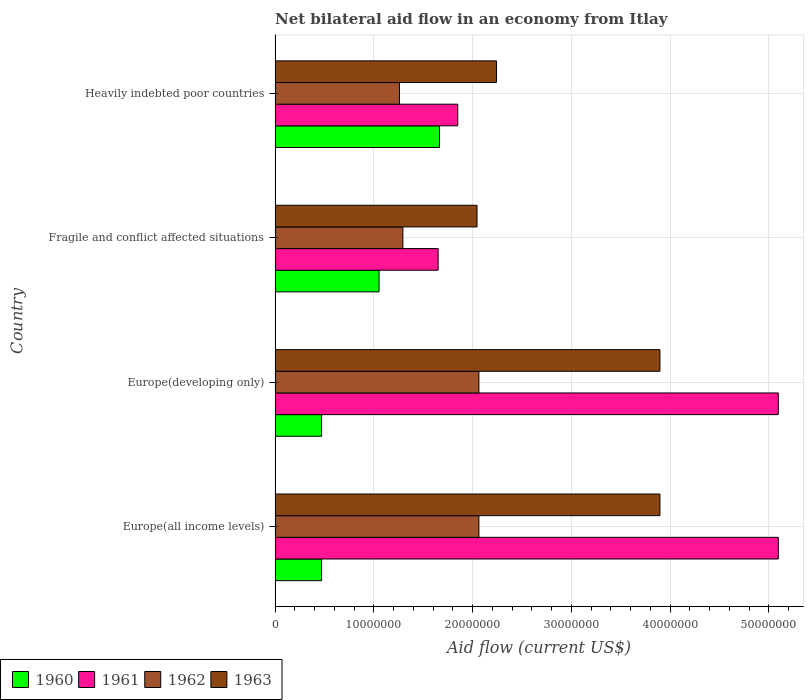Are the number of bars per tick equal to the number of legend labels?
Your answer should be very brief. Yes. Are the number of bars on each tick of the Y-axis equal?
Offer a terse response. Yes. How many bars are there on the 2nd tick from the top?
Your answer should be compact. 4. What is the label of the 4th group of bars from the top?
Ensure brevity in your answer.  Europe(all income levels). What is the net bilateral aid flow in 1963 in Europe(developing only)?
Provide a short and direct response. 3.90e+07. Across all countries, what is the maximum net bilateral aid flow in 1961?
Provide a succinct answer. 5.10e+07. Across all countries, what is the minimum net bilateral aid flow in 1960?
Your answer should be compact. 4.71e+06. In which country was the net bilateral aid flow in 1963 maximum?
Ensure brevity in your answer.  Europe(all income levels). In which country was the net bilateral aid flow in 1961 minimum?
Make the answer very short. Fragile and conflict affected situations. What is the total net bilateral aid flow in 1962 in the graph?
Your response must be concise. 6.68e+07. What is the difference between the net bilateral aid flow in 1961 in Fragile and conflict affected situations and that in Heavily indebted poor countries?
Ensure brevity in your answer.  -1.99e+06. What is the difference between the net bilateral aid flow in 1960 in Heavily indebted poor countries and the net bilateral aid flow in 1962 in Europe(all income levels)?
Offer a terse response. -3.99e+06. What is the average net bilateral aid flow in 1960 per country?
Offer a very short reply. 9.15e+06. What is the difference between the net bilateral aid flow in 1960 and net bilateral aid flow in 1961 in Fragile and conflict affected situations?
Ensure brevity in your answer.  -5.98e+06. What is the ratio of the net bilateral aid flow in 1961 in Europe(developing only) to that in Fragile and conflict affected situations?
Your answer should be compact. 3.09. Is the net bilateral aid flow in 1961 in Europe(all income levels) less than that in Europe(developing only)?
Your answer should be very brief. No. What is the difference between the highest and the second highest net bilateral aid flow in 1960?
Give a very brief answer. 6.12e+06. What is the difference between the highest and the lowest net bilateral aid flow in 1960?
Give a very brief answer. 1.19e+07. In how many countries, is the net bilateral aid flow in 1962 greater than the average net bilateral aid flow in 1962 taken over all countries?
Your response must be concise. 2. Is the sum of the net bilateral aid flow in 1960 in Europe(all income levels) and Heavily indebted poor countries greater than the maximum net bilateral aid flow in 1961 across all countries?
Offer a very short reply. No. What does the 4th bar from the top in Europe(all income levels) represents?
Provide a succinct answer. 1960. How many bars are there?
Your response must be concise. 16. What is the difference between two consecutive major ticks on the X-axis?
Make the answer very short. 1.00e+07. Does the graph contain any zero values?
Make the answer very short. No. Where does the legend appear in the graph?
Provide a short and direct response. Bottom left. How many legend labels are there?
Your response must be concise. 4. What is the title of the graph?
Your response must be concise. Net bilateral aid flow in an economy from Itlay. Does "2001" appear as one of the legend labels in the graph?
Keep it short and to the point. No. What is the label or title of the X-axis?
Your answer should be very brief. Aid flow (current US$). What is the label or title of the Y-axis?
Ensure brevity in your answer.  Country. What is the Aid flow (current US$) of 1960 in Europe(all income levels)?
Your answer should be compact. 4.71e+06. What is the Aid flow (current US$) in 1961 in Europe(all income levels)?
Ensure brevity in your answer.  5.10e+07. What is the Aid flow (current US$) in 1962 in Europe(all income levels)?
Give a very brief answer. 2.06e+07. What is the Aid flow (current US$) of 1963 in Europe(all income levels)?
Offer a very short reply. 3.90e+07. What is the Aid flow (current US$) of 1960 in Europe(developing only)?
Provide a short and direct response. 4.71e+06. What is the Aid flow (current US$) of 1961 in Europe(developing only)?
Make the answer very short. 5.10e+07. What is the Aid flow (current US$) of 1962 in Europe(developing only)?
Provide a succinct answer. 2.06e+07. What is the Aid flow (current US$) in 1963 in Europe(developing only)?
Your response must be concise. 3.90e+07. What is the Aid flow (current US$) of 1960 in Fragile and conflict affected situations?
Make the answer very short. 1.05e+07. What is the Aid flow (current US$) in 1961 in Fragile and conflict affected situations?
Your answer should be compact. 1.65e+07. What is the Aid flow (current US$) in 1962 in Fragile and conflict affected situations?
Offer a terse response. 1.29e+07. What is the Aid flow (current US$) of 1963 in Fragile and conflict affected situations?
Provide a short and direct response. 2.04e+07. What is the Aid flow (current US$) in 1960 in Heavily indebted poor countries?
Make the answer very short. 1.66e+07. What is the Aid flow (current US$) in 1961 in Heavily indebted poor countries?
Provide a short and direct response. 1.85e+07. What is the Aid flow (current US$) in 1962 in Heavily indebted poor countries?
Your answer should be compact. 1.26e+07. What is the Aid flow (current US$) in 1963 in Heavily indebted poor countries?
Ensure brevity in your answer.  2.24e+07. Across all countries, what is the maximum Aid flow (current US$) in 1960?
Your answer should be compact. 1.66e+07. Across all countries, what is the maximum Aid flow (current US$) in 1961?
Provide a succinct answer. 5.10e+07. Across all countries, what is the maximum Aid flow (current US$) in 1962?
Provide a succinct answer. 2.06e+07. Across all countries, what is the maximum Aid flow (current US$) in 1963?
Offer a terse response. 3.90e+07. Across all countries, what is the minimum Aid flow (current US$) of 1960?
Your answer should be compact. 4.71e+06. Across all countries, what is the minimum Aid flow (current US$) in 1961?
Your response must be concise. 1.65e+07. Across all countries, what is the minimum Aid flow (current US$) in 1962?
Provide a succinct answer. 1.26e+07. Across all countries, what is the minimum Aid flow (current US$) of 1963?
Ensure brevity in your answer.  2.04e+07. What is the total Aid flow (current US$) in 1960 in the graph?
Ensure brevity in your answer.  3.66e+07. What is the total Aid flow (current US$) in 1961 in the graph?
Your response must be concise. 1.37e+08. What is the total Aid flow (current US$) in 1962 in the graph?
Provide a short and direct response. 6.68e+07. What is the total Aid flow (current US$) of 1963 in the graph?
Give a very brief answer. 1.21e+08. What is the difference between the Aid flow (current US$) in 1960 in Europe(all income levels) and that in Europe(developing only)?
Make the answer very short. 0. What is the difference between the Aid flow (current US$) of 1962 in Europe(all income levels) and that in Europe(developing only)?
Your answer should be compact. 0. What is the difference between the Aid flow (current US$) in 1963 in Europe(all income levels) and that in Europe(developing only)?
Offer a terse response. 0. What is the difference between the Aid flow (current US$) of 1960 in Europe(all income levels) and that in Fragile and conflict affected situations?
Your answer should be very brief. -5.82e+06. What is the difference between the Aid flow (current US$) of 1961 in Europe(all income levels) and that in Fragile and conflict affected situations?
Make the answer very short. 3.44e+07. What is the difference between the Aid flow (current US$) in 1962 in Europe(all income levels) and that in Fragile and conflict affected situations?
Ensure brevity in your answer.  7.70e+06. What is the difference between the Aid flow (current US$) of 1963 in Europe(all income levels) and that in Fragile and conflict affected situations?
Ensure brevity in your answer.  1.85e+07. What is the difference between the Aid flow (current US$) in 1960 in Europe(all income levels) and that in Heavily indebted poor countries?
Your answer should be very brief. -1.19e+07. What is the difference between the Aid flow (current US$) in 1961 in Europe(all income levels) and that in Heavily indebted poor countries?
Your answer should be very brief. 3.25e+07. What is the difference between the Aid flow (current US$) in 1962 in Europe(all income levels) and that in Heavily indebted poor countries?
Your response must be concise. 8.04e+06. What is the difference between the Aid flow (current US$) in 1963 in Europe(all income levels) and that in Heavily indebted poor countries?
Provide a succinct answer. 1.66e+07. What is the difference between the Aid flow (current US$) in 1960 in Europe(developing only) and that in Fragile and conflict affected situations?
Offer a terse response. -5.82e+06. What is the difference between the Aid flow (current US$) in 1961 in Europe(developing only) and that in Fragile and conflict affected situations?
Ensure brevity in your answer.  3.44e+07. What is the difference between the Aid flow (current US$) of 1962 in Europe(developing only) and that in Fragile and conflict affected situations?
Your answer should be very brief. 7.70e+06. What is the difference between the Aid flow (current US$) in 1963 in Europe(developing only) and that in Fragile and conflict affected situations?
Give a very brief answer. 1.85e+07. What is the difference between the Aid flow (current US$) in 1960 in Europe(developing only) and that in Heavily indebted poor countries?
Your answer should be compact. -1.19e+07. What is the difference between the Aid flow (current US$) in 1961 in Europe(developing only) and that in Heavily indebted poor countries?
Ensure brevity in your answer.  3.25e+07. What is the difference between the Aid flow (current US$) in 1962 in Europe(developing only) and that in Heavily indebted poor countries?
Offer a very short reply. 8.04e+06. What is the difference between the Aid flow (current US$) in 1963 in Europe(developing only) and that in Heavily indebted poor countries?
Keep it short and to the point. 1.66e+07. What is the difference between the Aid flow (current US$) in 1960 in Fragile and conflict affected situations and that in Heavily indebted poor countries?
Your answer should be very brief. -6.12e+06. What is the difference between the Aid flow (current US$) in 1961 in Fragile and conflict affected situations and that in Heavily indebted poor countries?
Your answer should be compact. -1.99e+06. What is the difference between the Aid flow (current US$) in 1962 in Fragile and conflict affected situations and that in Heavily indebted poor countries?
Ensure brevity in your answer.  3.40e+05. What is the difference between the Aid flow (current US$) in 1963 in Fragile and conflict affected situations and that in Heavily indebted poor countries?
Ensure brevity in your answer.  -1.97e+06. What is the difference between the Aid flow (current US$) in 1960 in Europe(all income levels) and the Aid flow (current US$) in 1961 in Europe(developing only)?
Your response must be concise. -4.62e+07. What is the difference between the Aid flow (current US$) of 1960 in Europe(all income levels) and the Aid flow (current US$) of 1962 in Europe(developing only)?
Your answer should be very brief. -1.59e+07. What is the difference between the Aid flow (current US$) in 1960 in Europe(all income levels) and the Aid flow (current US$) in 1963 in Europe(developing only)?
Your answer should be compact. -3.43e+07. What is the difference between the Aid flow (current US$) of 1961 in Europe(all income levels) and the Aid flow (current US$) of 1962 in Europe(developing only)?
Offer a very short reply. 3.03e+07. What is the difference between the Aid flow (current US$) in 1961 in Europe(all income levels) and the Aid flow (current US$) in 1963 in Europe(developing only)?
Provide a short and direct response. 1.20e+07. What is the difference between the Aid flow (current US$) in 1962 in Europe(all income levels) and the Aid flow (current US$) in 1963 in Europe(developing only)?
Offer a very short reply. -1.83e+07. What is the difference between the Aid flow (current US$) of 1960 in Europe(all income levels) and the Aid flow (current US$) of 1961 in Fragile and conflict affected situations?
Your answer should be compact. -1.18e+07. What is the difference between the Aid flow (current US$) in 1960 in Europe(all income levels) and the Aid flow (current US$) in 1962 in Fragile and conflict affected situations?
Your answer should be compact. -8.23e+06. What is the difference between the Aid flow (current US$) of 1960 in Europe(all income levels) and the Aid flow (current US$) of 1963 in Fragile and conflict affected situations?
Your answer should be very brief. -1.57e+07. What is the difference between the Aid flow (current US$) of 1961 in Europe(all income levels) and the Aid flow (current US$) of 1962 in Fragile and conflict affected situations?
Provide a succinct answer. 3.80e+07. What is the difference between the Aid flow (current US$) in 1961 in Europe(all income levels) and the Aid flow (current US$) in 1963 in Fragile and conflict affected situations?
Your response must be concise. 3.05e+07. What is the difference between the Aid flow (current US$) in 1960 in Europe(all income levels) and the Aid flow (current US$) in 1961 in Heavily indebted poor countries?
Your answer should be compact. -1.38e+07. What is the difference between the Aid flow (current US$) of 1960 in Europe(all income levels) and the Aid flow (current US$) of 1962 in Heavily indebted poor countries?
Provide a succinct answer. -7.89e+06. What is the difference between the Aid flow (current US$) of 1960 in Europe(all income levels) and the Aid flow (current US$) of 1963 in Heavily indebted poor countries?
Offer a very short reply. -1.77e+07. What is the difference between the Aid flow (current US$) in 1961 in Europe(all income levels) and the Aid flow (current US$) in 1962 in Heavily indebted poor countries?
Offer a terse response. 3.84e+07. What is the difference between the Aid flow (current US$) in 1961 in Europe(all income levels) and the Aid flow (current US$) in 1963 in Heavily indebted poor countries?
Your response must be concise. 2.85e+07. What is the difference between the Aid flow (current US$) in 1962 in Europe(all income levels) and the Aid flow (current US$) in 1963 in Heavily indebted poor countries?
Provide a succinct answer. -1.78e+06. What is the difference between the Aid flow (current US$) of 1960 in Europe(developing only) and the Aid flow (current US$) of 1961 in Fragile and conflict affected situations?
Your response must be concise. -1.18e+07. What is the difference between the Aid flow (current US$) in 1960 in Europe(developing only) and the Aid flow (current US$) in 1962 in Fragile and conflict affected situations?
Offer a terse response. -8.23e+06. What is the difference between the Aid flow (current US$) of 1960 in Europe(developing only) and the Aid flow (current US$) of 1963 in Fragile and conflict affected situations?
Provide a succinct answer. -1.57e+07. What is the difference between the Aid flow (current US$) in 1961 in Europe(developing only) and the Aid flow (current US$) in 1962 in Fragile and conflict affected situations?
Your response must be concise. 3.80e+07. What is the difference between the Aid flow (current US$) in 1961 in Europe(developing only) and the Aid flow (current US$) in 1963 in Fragile and conflict affected situations?
Your answer should be very brief. 3.05e+07. What is the difference between the Aid flow (current US$) in 1960 in Europe(developing only) and the Aid flow (current US$) in 1961 in Heavily indebted poor countries?
Ensure brevity in your answer.  -1.38e+07. What is the difference between the Aid flow (current US$) of 1960 in Europe(developing only) and the Aid flow (current US$) of 1962 in Heavily indebted poor countries?
Give a very brief answer. -7.89e+06. What is the difference between the Aid flow (current US$) of 1960 in Europe(developing only) and the Aid flow (current US$) of 1963 in Heavily indebted poor countries?
Provide a short and direct response. -1.77e+07. What is the difference between the Aid flow (current US$) in 1961 in Europe(developing only) and the Aid flow (current US$) in 1962 in Heavily indebted poor countries?
Your response must be concise. 3.84e+07. What is the difference between the Aid flow (current US$) in 1961 in Europe(developing only) and the Aid flow (current US$) in 1963 in Heavily indebted poor countries?
Give a very brief answer. 2.85e+07. What is the difference between the Aid flow (current US$) of 1962 in Europe(developing only) and the Aid flow (current US$) of 1963 in Heavily indebted poor countries?
Provide a short and direct response. -1.78e+06. What is the difference between the Aid flow (current US$) in 1960 in Fragile and conflict affected situations and the Aid flow (current US$) in 1961 in Heavily indebted poor countries?
Provide a short and direct response. -7.97e+06. What is the difference between the Aid flow (current US$) of 1960 in Fragile and conflict affected situations and the Aid flow (current US$) of 1962 in Heavily indebted poor countries?
Your answer should be compact. -2.07e+06. What is the difference between the Aid flow (current US$) of 1960 in Fragile and conflict affected situations and the Aid flow (current US$) of 1963 in Heavily indebted poor countries?
Your answer should be compact. -1.19e+07. What is the difference between the Aid flow (current US$) of 1961 in Fragile and conflict affected situations and the Aid flow (current US$) of 1962 in Heavily indebted poor countries?
Make the answer very short. 3.91e+06. What is the difference between the Aid flow (current US$) of 1961 in Fragile and conflict affected situations and the Aid flow (current US$) of 1963 in Heavily indebted poor countries?
Offer a terse response. -5.91e+06. What is the difference between the Aid flow (current US$) in 1962 in Fragile and conflict affected situations and the Aid flow (current US$) in 1963 in Heavily indebted poor countries?
Offer a terse response. -9.48e+06. What is the average Aid flow (current US$) in 1960 per country?
Your answer should be very brief. 9.15e+06. What is the average Aid flow (current US$) in 1961 per country?
Your response must be concise. 3.42e+07. What is the average Aid flow (current US$) in 1962 per country?
Give a very brief answer. 1.67e+07. What is the average Aid flow (current US$) in 1963 per country?
Offer a terse response. 3.02e+07. What is the difference between the Aid flow (current US$) of 1960 and Aid flow (current US$) of 1961 in Europe(all income levels)?
Your response must be concise. -4.62e+07. What is the difference between the Aid flow (current US$) of 1960 and Aid flow (current US$) of 1962 in Europe(all income levels)?
Keep it short and to the point. -1.59e+07. What is the difference between the Aid flow (current US$) of 1960 and Aid flow (current US$) of 1963 in Europe(all income levels)?
Offer a very short reply. -3.43e+07. What is the difference between the Aid flow (current US$) of 1961 and Aid flow (current US$) of 1962 in Europe(all income levels)?
Your response must be concise. 3.03e+07. What is the difference between the Aid flow (current US$) in 1961 and Aid flow (current US$) in 1963 in Europe(all income levels)?
Your answer should be very brief. 1.20e+07. What is the difference between the Aid flow (current US$) in 1962 and Aid flow (current US$) in 1963 in Europe(all income levels)?
Your answer should be compact. -1.83e+07. What is the difference between the Aid flow (current US$) of 1960 and Aid flow (current US$) of 1961 in Europe(developing only)?
Keep it short and to the point. -4.62e+07. What is the difference between the Aid flow (current US$) in 1960 and Aid flow (current US$) in 1962 in Europe(developing only)?
Offer a very short reply. -1.59e+07. What is the difference between the Aid flow (current US$) of 1960 and Aid flow (current US$) of 1963 in Europe(developing only)?
Your answer should be compact. -3.43e+07. What is the difference between the Aid flow (current US$) of 1961 and Aid flow (current US$) of 1962 in Europe(developing only)?
Give a very brief answer. 3.03e+07. What is the difference between the Aid flow (current US$) in 1961 and Aid flow (current US$) in 1963 in Europe(developing only)?
Provide a succinct answer. 1.20e+07. What is the difference between the Aid flow (current US$) of 1962 and Aid flow (current US$) of 1963 in Europe(developing only)?
Keep it short and to the point. -1.83e+07. What is the difference between the Aid flow (current US$) in 1960 and Aid flow (current US$) in 1961 in Fragile and conflict affected situations?
Offer a very short reply. -5.98e+06. What is the difference between the Aid flow (current US$) in 1960 and Aid flow (current US$) in 1962 in Fragile and conflict affected situations?
Make the answer very short. -2.41e+06. What is the difference between the Aid flow (current US$) in 1960 and Aid flow (current US$) in 1963 in Fragile and conflict affected situations?
Your response must be concise. -9.92e+06. What is the difference between the Aid flow (current US$) in 1961 and Aid flow (current US$) in 1962 in Fragile and conflict affected situations?
Provide a succinct answer. 3.57e+06. What is the difference between the Aid flow (current US$) of 1961 and Aid flow (current US$) of 1963 in Fragile and conflict affected situations?
Offer a terse response. -3.94e+06. What is the difference between the Aid flow (current US$) in 1962 and Aid flow (current US$) in 1963 in Fragile and conflict affected situations?
Offer a terse response. -7.51e+06. What is the difference between the Aid flow (current US$) of 1960 and Aid flow (current US$) of 1961 in Heavily indebted poor countries?
Your response must be concise. -1.85e+06. What is the difference between the Aid flow (current US$) in 1960 and Aid flow (current US$) in 1962 in Heavily indebted poor countries?
Ensure brevity in your answer.  4.05e+06. What is the difference between the Aid flow (current US$) of 1960 and Aid flow (current US$) of 1963 in Heavily indebted poor countries?
Offer a terse response. -5.77e+06. What is the difference between the Aid flow (current US$) of 1961 and Aid flow (current US$) of 1962 in Heavily indebted poor countries?
Your response must be concise. 5.90e+06. What is the difference between the Aid flow (current US$) of 1961 and Aid flow (current US$) of 1963 in Heavily indebted poor countries?
Offer a very short reply. -3.92e+06. What is the difference between the Aid flow (current US$) in 1962 and Aid flow (current US$) in 1963 in Heavily indebted poor countries?
Provide a short and direct response. -9.82e+06. What is the ratio of the Aid flow (current US$) in 1960 in Europe(all income levels) to that in Europe(developing only)?
Your response must be concise. 1. What is the ratio of the Aid flow (current US$) of 1961 in Europe(all income levels) to that in Europe(developing only)?
Offer a very short reply. 1. What is the ratio of the Aid flow (current US$) of 1962 in Europe(all income levels) to that in Europe(developing only)?
Make the answer very short. 1. What is the ratio of the Aid flow (current US$) in 1960 in Europe(all income levels) to that in Fragile and conflict affected situations?
Ensure brevity in your answer.  0.45. What is the ratio of the Aid flow (current US$) in 1961 in Europe(all income levels) to that in Fragile and conflict affected situations?
Your answer should be very brief. 3.09. What is the ratio of the Aid flow (current US$) in 1962 in Europe(all income levels) to that in Fragile and conflict affected situations?
Give a very brief answer. 1.6. What is the ratio of the Aid flow (current US$) of 1963 in Europe(all income levels) to that in Fragile and conflict affected situations?
Keep it short and to the point. 1.91. What is the ratio of the Aid flow (current US$) in 1960 in Europe(all income levels) to that in Heavily indebted poor countries?
Offer a very short reply. 0.28. What is the ratio of the Aid flow (current US$) of 1961 in Europe(all income levels) to that in Heavily indebted poor countries?
Offer a very short reply. 2.75. What is the ratio of the Aid flow (current US$) in 1962 in Europe(all income levels) to that in Heavily indebted poor countries?
Give a very brief answer. 1.64. What is the ratio of the Aid flow (current US$) of 1963 in Europe(all income levels) to that in Heavily indebted poor countries?
Provide a short and direct response. 1.74. What is the ratio of the Aid flow (current US$) of 1960 in Europe(developing only) to that in Fragile and conflict affected situations?
Your answer should be compact. 0.45. What is the ratio of the Aid flow (current US$) of 1961 in Europe(developing only) to that in Fragile and conflict affected situations?
Provide a succinct answer. 3.09. What is the ratio of the Aid flow (current US$) in 1962 in Europe(developing only) to that in Fragile and conflict affected situations?
Give a very brief answer. 1.6. What is the ratio of the Aid flow (current US$) in 1963 in Europe(developing only) to that in Fragile and conflict affected situations?
Offer a terse response. 1.91. What is the ratio of the Aid flow (current US$) of 1960 in Europe(developing only) to that in Heavily indebted poor countries?
Offer a terse response. 0.28. What is the ratio of the Aid flow (current US$) of 1961 in Europe(developing only) to that in Heavily indebted poor countries?
Offer a terse response. 2.75. What is the ratio of the Aid flow (current US$) of 1962 in Europe(developing only) to that in Heavily indebted poor countries?
Your answer should be compact. 1.64. What is the ratio of the Aid flow (current US$) of 1963 in Europe(developing only) to that in Heavily indebted poor countries?
Provide a short and direct response. 1.74. What is the ratio of the Aid flow (current US$) in 1960 in Fragile and conflict affected situations to that in Heavily indebted poor countries?
Your answer should be compact. 0.63. What is the ratio of the Aid flow (current US$) in 1961 in Fragile and conflict affected situations to that in Heavily indebted poor countries?
Offer a terse response. 0.89. What is the ratio of the Aid flow (current US$) in 1962 in Fragile and conflict affected situations to that in Heavily indebted poor countries?
Ensure brevity in your answer.  1.03. What is the ratio of the Aid flow (current US$) in 1963 in Fragile and conflict affected situations to that in Heavily indebted poor countries?
Provide a succinct answer. 0.91. What is the difference between the highest and the second highest Aid flow (current US$) of 1960?
Make the answer very short. 6.12e+06. What is the difference between the highest and the second highest Aid flow (current US$) of 1962?
Make the answer very short. 0. What is the difference between the highest and the second highest Aid flow (current US$) in 1963?
Provide a short and direct response. 0. What is the difference between the highest and the lowest Aid flow (current US$) in 1960?
Provide a succinct answer. 1.19e+07. What is the difference between the highest and the lowest Aid flow (current US$) of 1961?
Ensure brevity in your answer.  3.44e+07. What is the difference between the highest and the lowest Aid flow (current US$) in 1962?
Ensure brevity in your answer.  8.04e+06. What is the difference between the highest and the lowest Aid flow (current US$) of 1963?
Offer a terse response. 1.85e+07. 